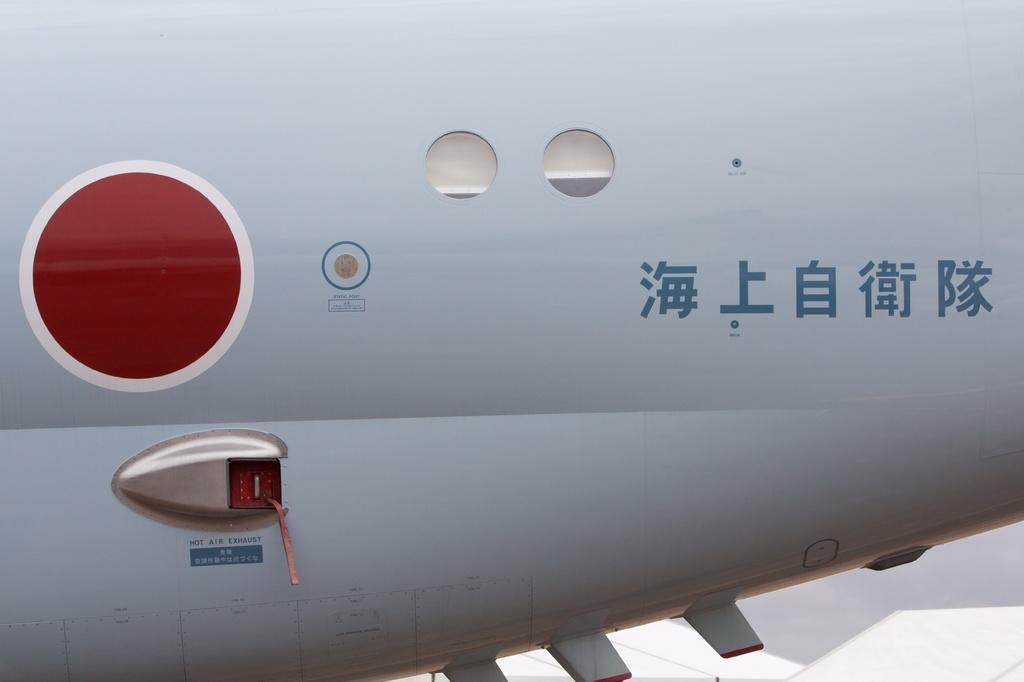In one or two sentences, can you explain what this image depicts? In the image there is a back part of the plain. On that there are windows, round shape with red color filled in it. And also there is an item on it. 